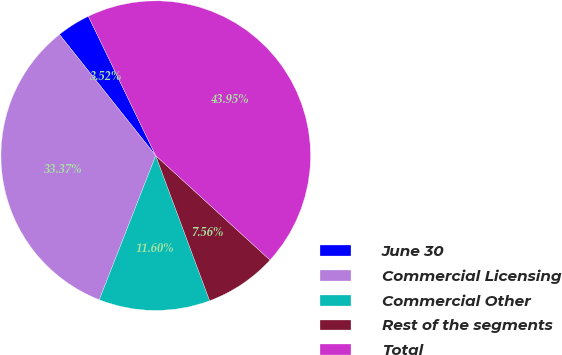Convert chart to OTSL. <chart><loc_0><loc_0><loc_500><loc_500><pie_chart><fcel>June 30<fcel>Commercial Licensing<fcel>Commercial Other<fcel>Rest of the segments<fcel>Total<nl><fcel>3.52%<fcel>33.37%<fcel>11.6%<fcel>7.56%<fcel>43.95%<nl></chart> 